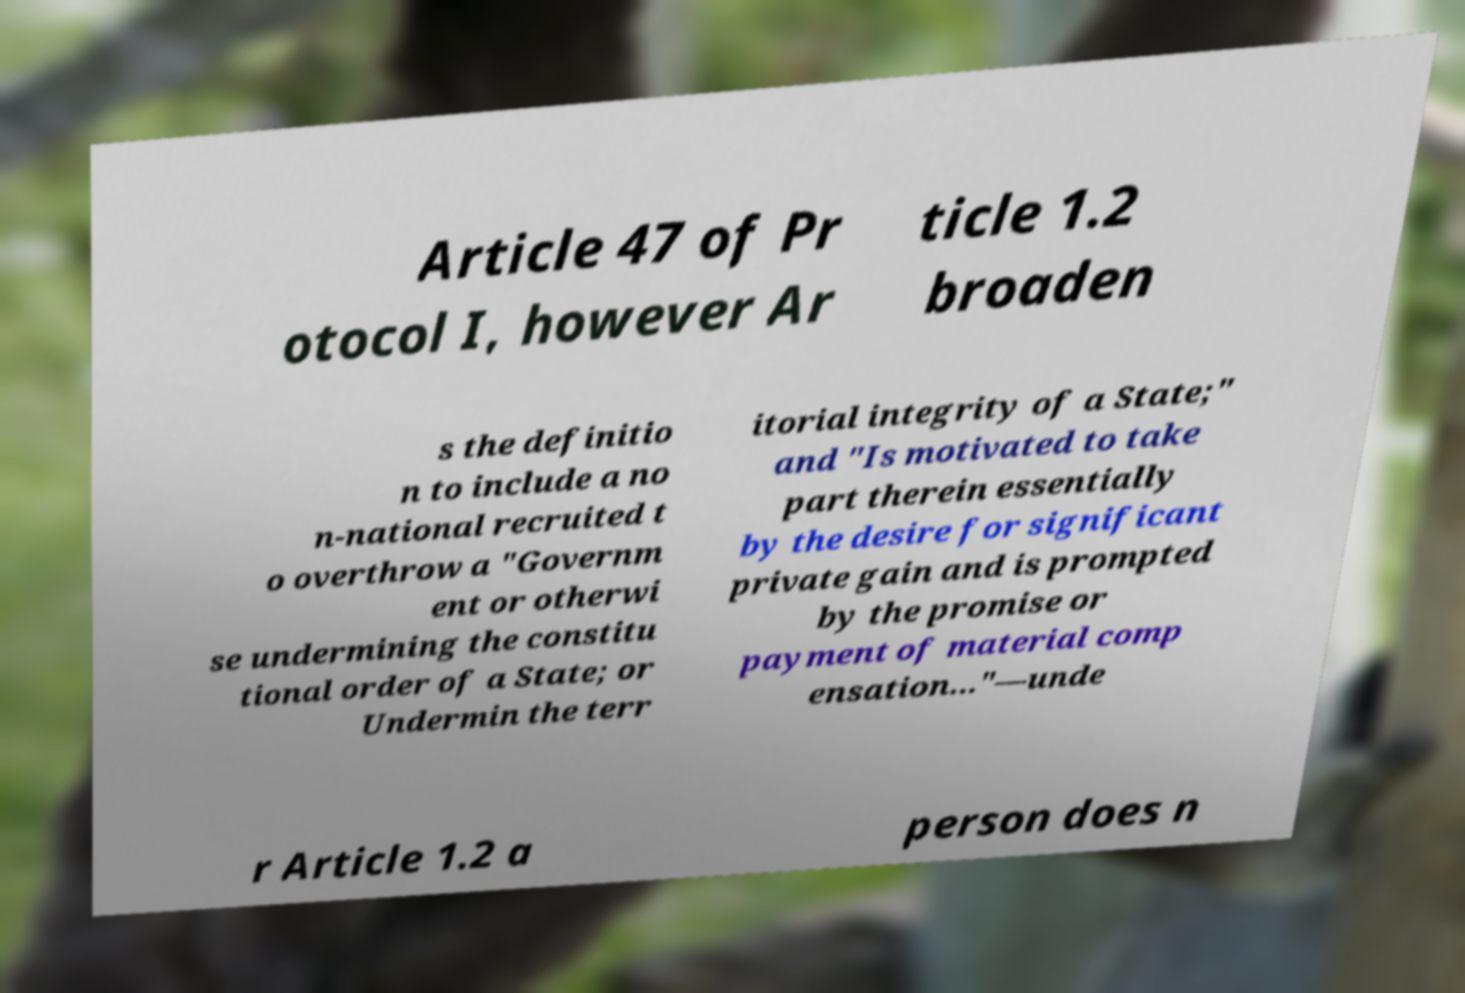Please identify and transcribe the text found in this image. Article 47 of Pr otocol I, however Ar ticle 1.2 broaden s the definitio n to include a no n-national recruited t o overthrow a "Governm ent or otherwi se undermining the constitu tional order of a State; or Undermin the terr itorial integrity of a State;" and "Is motivated to take part therein essentially by the desire for significant private gain and is prompted by the promise or payment of material comp ensation..."—unde r Article 1.2 a person does n 